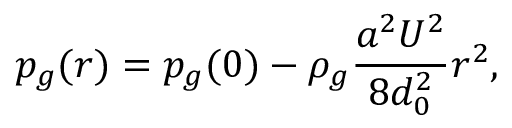<formula> <loc_0><loc_0><loc_500><loc_500>p _ { g } ( r ) = p _ { g } ( 0 ) - \rho _ { g } \frac { a ^ { 2 } U ^ { 2 } } { 8 d _ { 0 } ^ { 2 } } r ^ { 2 } ,</formula> 